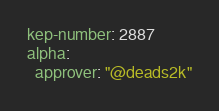Convert code to text. <code><loc_0><loc_0><loc_500><loc_500><_YAML_>kep-number: 2887
alpha:
  approver: "@deads2k"
</code> 